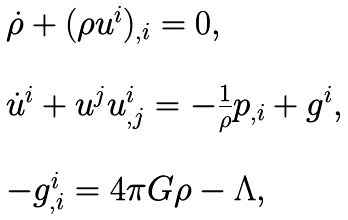Convert formula to latex. <formula><loc_0><loc_0><loc_500><loc_500>\begin{array} { l } \dot { \rho } + ( \rho u ^ { i } ) _ { , i } = 0 , \\ \\ \dot { u } ^ { i } + u ^ { j } u ^ { i } _ { , j } = - \frac { 1 } { \rho } p _ { , i } + g ^ { i } , \\ \\ - g ^ { i } _ { , i } = 4 \pi G \rho - \Lambda , \end{array}</formula> 